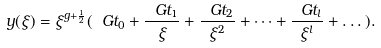Convert formula to latex. <formula><loc_0><loc_0><loc_500><loc_500>y ( \xi ) = \xi ^ { g + \frac { 1 } { 2 } } ( \ G t _ { 0 } + \frac { \ G t _ { 1 } } { \xi } + \frac { \ G t _ { 2 } } { \xi ^ { 2 } } + \dots + \frac { \ G t _ { l } } { \xi ^ { l } } + \dots ) .</formula> 